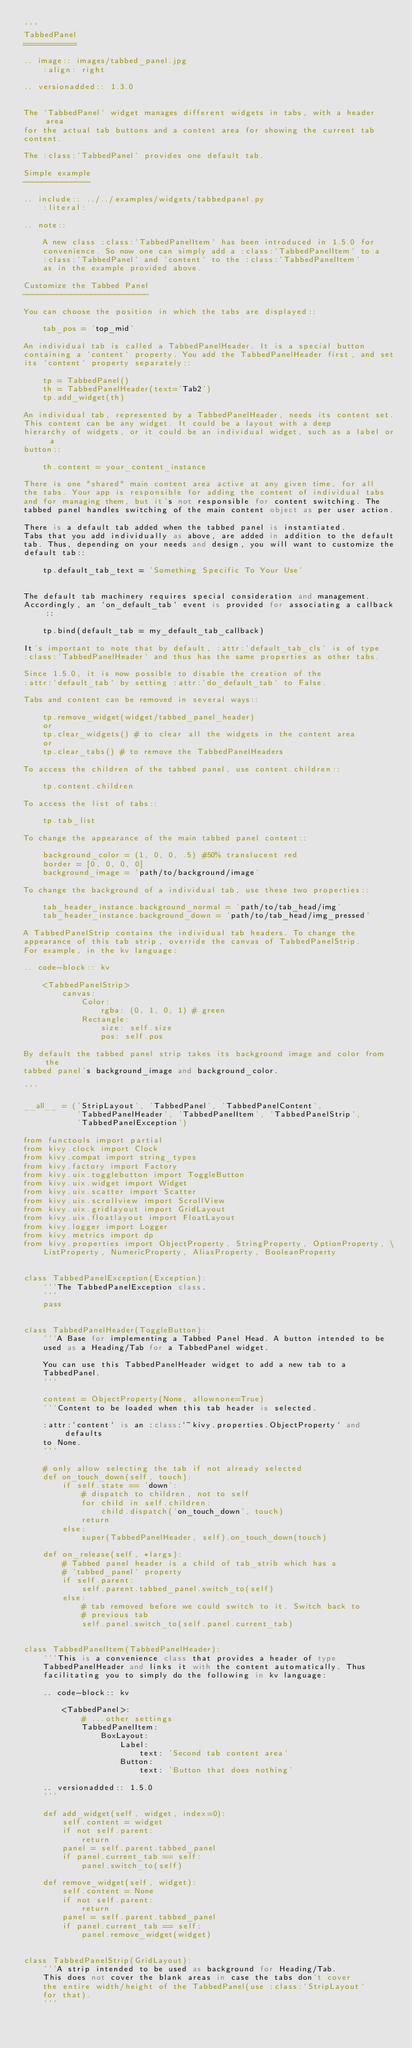<code> <loc_0><loc_0><loc_500><loc_500><_Python_>'''
TabbedPanel
===========

.. image:: images/tabbed_panel.jpg
    :align: right

.. versionadded:: 1.3.0


The `TabbedPanel` widget manages different widgets in tabs, with a header area
for the actual tab buttons and a content area for showing the current tab
content.

The :class:`TabbedPanel` provides one default tab.

Simple example
--------------

.. include:: ../../examples/widgets/tabbedpanel.py
    :literal:

.. note::

    A new class :class:`TabbedPanelItem` has been introduced in 1.5.0 for
    convenience. So now one can simply add a :class:`TabbedPanelItem` to a
    :class:`TabbedPanel` and `content` to the :class:`TabbedPanelItem`
    as in the example provided above.

Customize the Tabbed Panel
--------------------------

You can choose the position in which the tabs are displayed::

    tab_pos = 'top_mid'

An individual tab is called a TabbedPanelHeader. It is a special button
containing a `content` property. You add the TabbedPanelHeader first, and set
its `content` property separately::

    tp = TabbedPanel()
    th = TabbedPanelHeader(text='Tab2')
    tp.add_widget(th)

An individual tab, represented by a TabbedPanelHeader, needs its content set.
This content can be any widget. It could be a layout with a deep
hierarchy of widgets, or it could be an individual widget, such as a label or a
button::

    th.content = your_content_instance

There is one "shared" main content area active at any given time, for all
the tabs. Your app is responsible for adding the content of individual tabs
and for managing them, but it's not responsible for content switching. The
tabbed panel handles switching of the main content object as per user action.

There is a default tab added when the tabbed panel is instantiated.
Tabs that you add individually as above, are added in addition to the default
tab. Thus, depending on your needs and design, you will want to customize the
default tab::

    tp.default_tab_text = 'Something Specific To Your Use'


The default tab machinery requires special consideration and management.
Accordingly, an `on_default_tab` event is provided for associating a callback::

    tp.bind(default_tab = my_default_tab_callback)

It's important to note that by default, :attr:`default_tab_cls` is of type
:class:`TabbedPanelHeader` and thus has the same properties as other tabs.

Since 1.5.0, it is now possible to disable the creation of the
:attr:`default_tab` by setting :attr:`do_default_tab` to False.

Tabs and content can be removed in several ways::

    tp.remove_widget(widget/tabbed_panel_header)
    or
    tp.clear_widgets() # to clear all the widgets in the content area
    or
    tp.clear_tabs() # to remove the TabbedPanelHeaders

To access the children of the tabbed panel, use content.children::

    tp.content.children

To access the list of tabs::

    tp.tab_list

To change the appearance of the main tabbed panel content::

    background_color = (1, 0, 0, .5) #50% translucent red
    border = [0, 0, 0, 0]
    background_image = 'path/to/background/image'

To change the background of a individual tab, use these two properties::

    tab_header_instance.background_normal = 'path/to/tab_head/img'
    tab_header_instance.background_down = 'path/to/tab_head/img_pressed'

A TabbedPanelStrip contains the individual tab headers. To change the
appearance of this tab strip, override the canvas of TabbedPanelStrip.
For example, in the kv language:

.. code-block:: kv

    <TabbedPanelStrip>
        canvas:
            Color:
                rgba: (0, 1, 0, 1) # green
            Rectangle:
                size: self.size
                pos: self.pos

By default the tabbed panel strip takes its background image and color from the
tabbed panel's background_image and background_color.

'''

__all__ = ('StripLayout', 'TabbedPanel', 'TabbedPanelContent',
           'TabbedPanelHeader', 'TabbedPanelItem', 'TabbedPanelStrip',
           'TabbedPanelException')

from functools import partial
from kivy.clock import Clock
from kivy.compat import string_types
from kivy.factory import Factory
from kivy.uix.togglebutton import ToggleButton
from kivy.uix.widget import Widget
from kivy.uix.scatter import Scatter
from kivy.uix.scrollview import ScrollView
from kivy.uix.gridlayout import GridLayout
from kivy.uix.floatlayout import FloatLayout
from kivy.logger import Logger
from kivy.metrics import dp
from kivy.properties import ObjectProperty, StringProperty, OptionProperty, \
    ListProperty, NumericProperty, AliasProperty, BooleanProperty


class TabbedPanelException(Exception):
    '''The TabbedPanelException class.
    '''
    pass


class TabbedPanelHeader(ToggleButton):
    '''A Base for implementing a Tabbed Panel Head. A button intended to be
    used as a Heading/Tab for a TabbedPanel widget.

    You can use this TabbedPanelHeader widget to add a new tab to a
    TabbedPanel.
    '''

    content = ObjectProperty(None, allownone=True)
    '''Content to be loaded when this tab header is selected.

    :attr:`content` is an :class:`~kivy.properties.ObjectProperty` and defaults
    to None.
    '''

    # only allow selecting the tab if not already selected
    def on_touch_down(self, touch):
        if self.state == 'down':
            # dispatch to children, not to self
            for child in self.children:
                child.dispatch('on_touch_down', touch)
            return
        else:
            super(TabbedPanelHeader, self).on_touch_down(touch)

    def on_release(self, *largs):
        # Tabbed panel header is a child of tab_strib which has a
        # `tabbed_panel` property
        if self.parent:
            self.parent.tabbed_panel.switch_to(self)
        else:
            # tab removed before we could switch to it. Switch back to
            # previous tab
            self.panel.switch_to(self.panel.current_tab)


class TabbedPanelItem(TabbedPanelHeader):
    '''This is a convenience class that provides a header of type
    TabbedPanelHeader and links it with the content automatically. Thus
    facilitating you to simply do the following in kv language:

    .. code-block:: kv

        <TabbedPanel>:
            # ...other settings
            TabbedPanelItem:
                BoxLayout:
                    Label:
                        text: 'Second tab content area'
                    Button:
                        text: 'Button that does nothing'

    .. versionadded:: 1.5.0
    '''

    def add_widget(self, widget, index=0):
        self.content = widget
        if not self.parent:
            return
        panel = self.parent.tabbed_panel
        if panel.current_tab == self:
            panel.switch_to(self)

    def remove_widget(self, widget):
        self.content = None
        if not self.parent:
            return
        panel = self.parent.tabbed_panel
        if panel.current_tab == self:
            panel.remove_widget(widget)


class TabbedPanelStrip(GridLayout):
    '''A strip intended to be used as background for Heading/Tab.
    This does not cover the blank areas in case the tabs don't cover
    the entire width/height of the TabbedPanel(use :class:`StripLayout`
    for that).
    '''</code> 